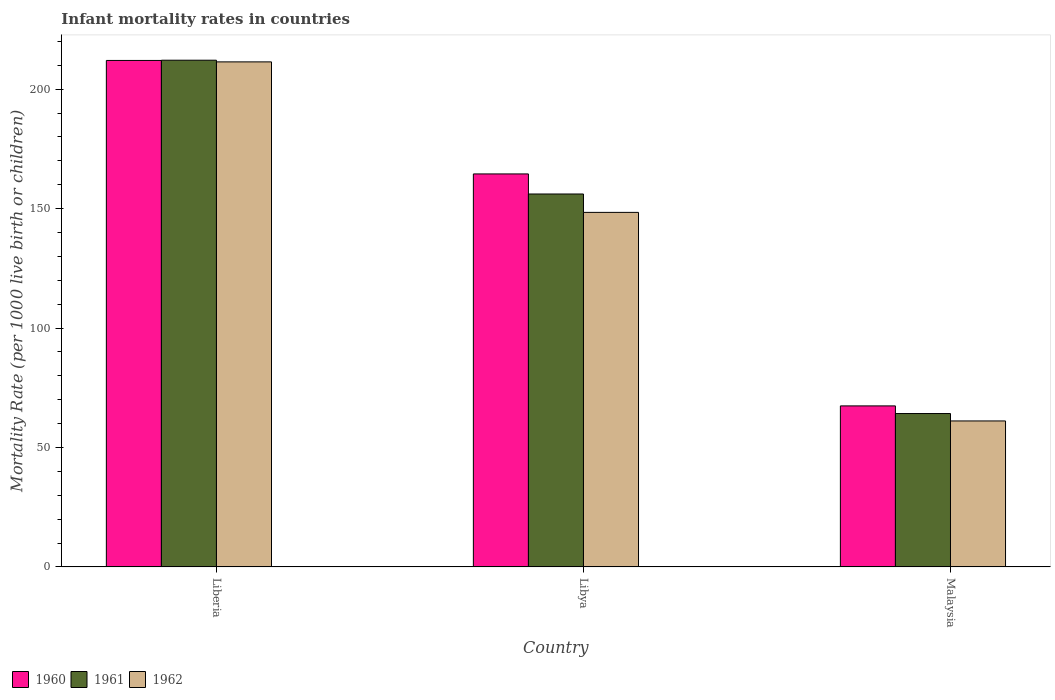How many different coloured bars are there?
Give a very brief answer. 3. How many bars are there on the 2nd tick from the right?
Make the answer very short. 3. What is the label of the 3rd group of bars from the left?
Ensure brevity in your answer.  Malaysia. What is the infant mortality rate in 1960 in Libya?
Your response must be concise. 164.5. Across all countries, what is the maximum infant mortality rate in 1961?
Offer a terse response. 212.1. Across all countries, what is the minimum infant mortality rate in 1961?
Provide a short and direct response. 64.2. In which country was the infant mortality rate in 1960 maximum?
Offer a terse response. Liberia. In which country was the infant mortality rate in 1960 minimum?
Make the answer very short. Malaysia. What is the total infant mortality rate in 1962 in the graph?
Give a very brief answer. 420.9. What is the difference between the infant mortality rate in 1962 in Liberia and that in Malaysia?
Provide a short and direct response. 150.3. What is the difference between the infant mortality rate in 1960 in Libya and the infant mortality rate in 1962 in Liberia?
Provide a succinct answer. -46.9. What is the average infant mortality rate in 1962 per country?
Make the answer very short. 140.3. What is the difference between the infant mortality rate of/in 1962 and infant mortality rate of/in 1960 in Liberia?
Your answer should be compact. -0.6. In how many countries, is the infant mortality rate in 1961 greater than 110?
Give a very brief answer. 2. What is the ratio of the infant mortality rate in 1960 in Liberia to that in Malaysia?
Offer a terse response. 3.15. Is the difference between the infant mortality rate in 1962 in Liberia and Malaysia greater than the difference between the infant mortality rate in 1960 in Liberia and Malaysia?
Your answer should be compact. Yes. What is the difference between the highest and the lowest infant mortality rate in 1961?
Keep it short and to the point. 147.9. What does the 1st bar from the left in Liberia represents?
Make the answer very short. 1960. Is it the case that in every country, the sum of the infant mortality rate in 1962 and infant mortality rate in 1961 is greater than the infant mortality rate in 1960?
Provide a succinct answer. Yes. How many bars are there?
Give a very brief answer. 9. Are all the bars in the graph horizontal?
Ensure brevity in your answer.  No. Does the graph contain grids?
Offer a terse response. No. What is the title of the graph?
Provide a short and direct response. Infant mortality rates in countries. Does "1974" appear as one of the legend labels in the graph?
Your answer should be very brief. No. What is the label or title of the X-axis?
Keep it short and to the point. Country. What is the label or title of the Y-axis?
Keep it short and to the point. Mortality Rate (per 1000 live birth or children). What is the Mortality Rate (per 1000 live birth or children) of 1960 in Liberia?
Provide a succinct answer. 212. What is the Mortality Rate (per 1000 live birth or children) of 1961 in Liberia?
Give a very brief answer. 212.1. What is the Mortality Rate (per 1000 live birth or children) in 1962 in Liberia?
Offer a terse response. 211.4. What is the Mortality Rate (per 1000 live birth or children) of 1960 in Libya?
Provide a short and direct response. 164.5. What is the Mortality Rate (per 1000 live birth or children) in 1961 in Libya?
Provide a succinct answer. 156.1. What is the Mortality Rate (per 1000 live birth or children) of 1962 in Libya?
Keep it short and to the point. 148.4. What is the Mortality Rate (per 1000 live birth or children) of 1960 in Malaysia?
Keep it short and to the point. 67.4. What is the Mortality Rate (per 1000 live birth or children) of 1961 in Malaysia?
Your response must be concise. 64.2. What is the Mortality Rate (per 1000 live birth or children) in 1962 in Malaysia?
Offer a very short reply. 61.1. Across all countries, what is the maximum Mortality Rate (per 1000 live birth or children) of 1960?
Keep it short and to the point. 212. Across all countries, what is the maximum Mortality Rate (per 1000 live birth or children) of 1961?
Provide a short and direct response. 212.1. Across all countries, what is the maximum Mortality Rate (per 1000 live birth or children) in 1962?
Provide a short and direct response. 211.4. Across all countries, what is the minimum Mortality Rate (per 1000 live birth or children) in 1960?
Offer a terse response. 67.4. Across all countries, what is the minimum Mortality Rate (per 1000 live birth or children) in 1961?
Offer a terse response. 64.2. Across all countries, what is the minimum Mortality Rate (per 1000 live birth or children) in 1962?
Offer a very short reply. 61.1. What is the total Mortality Rate (per 1000 live birth or children) of 1960 in the graph?
Ensure brevity in your answer.  443.9. What is the total Mortality Rate (per 1000 live birth or children) of 1961 in the graph?
Offer a terse response. 432.4. What is the total Mortality Rate (per 1000 live birth or children) in 1962 in the graph?
Keep it short and to the point. 420.9. What is the difference between the Mortality Rate (per 1000 live birth or children) of 1960 in Liberia and that in Libya?
Your response must be concise. 47.5. What is the difference between the Mortality Rate (per 1000 live birth or children) of 1962 in Liberia and that in Libya?
Your response must be concise. 63. What is the difference between the Mortality Rate (per 1000 live birth or children) in 1960 in Liberia and that in Malaysia?
Offer a terse response. 144.6. What is the difference between the Mortality Rate (per 1000 live birth or children) of 1961 in Liberia and that in Malaysia?
Offer a terse response. 147.9. What is the difference between the Mortality Rate (per 1000 live birth or children) in 1962 in Liberia and that in Malaysia?
Keep it short and to the point. 150.3. What is the difference between the Mortality Rate (per 1000 live birth or children) in 1960 in Libya and that in Malaysia?
Provide a succinct answer. 97.1. What is the difference between the Mortality Rate (per 1000 live birth or children) of 1961 in Libya and that in Malaysia?
Keep it short and to the point. 91.9. What is the difference between the Mortality Rate (per 1000 live birth or children) of 1962 in Libya and that in Malaysia?
Your response must be concise. 87.3. What is the difference between the Mortality Rate (per 1000 live birth or children) in 1960 in Liberia and the Mortality Rate (per 1000 live birth or children) in 1961 in Libya?
Provide a short and direct response. 55.9. What is the difference between the Mortality Rate (per 1000 live birth or children) of 1960 in Liberia and the Mortality Rate (per 1000 live birth or children) of 1962 in Libya?
Your response must be concise. 63.6. What is the difference between the Mortality Rate (per 1000 live birth or children) in 1961 in Liberia and the Mortality Rate (per 1000 live birth or children) in 1962 in Libya?
Keep it short and to the point. 63.7. What is the difference between the Mortality Rate (per 1000 live birth or children) of 1960 in Liberia and the Mortality Rate (per 1000 live birth or children) of 1961 in Malaysia?
Make the answer very short. 147.8. What is the difference between the Mortality Rate (per 1000 live birth or children) in 1960 in Liberia and the Mortality Rate (per 1000 live birth or children) in 1962 in Malaysia?
Keep it short and to the point. 150.9. What is the difference between the Mortality Rate (per 1000 live birth or children) in 1961 in Liberia and the Mortality Rate (per 1000 live birth or children) in 1962 in Malaysia?
Your answer should be compact. 151. What is the difference between the Mortality Rate (per 1000 live birth or children) in 1960 in Libya and the Mortality Rate (per 1000 live birth or children) in 1961 in Malaysia?
Your answer should be very brief. 100.3. What is the difference between the Mortality Rate (per 1000 live birth or children) in 1960 in Libya and the Mortality Rate (per 1000 live birth or children) in 1962 in Malaysia?
Your response must be concise. 103.4. What is the difference between the Mortality Rate (per 1000 live birth or children) of 1961 in Libya and the Mortality Rate (per 1000 live birth or children) of 1962 in Malaysia?
Ensure brevity in your answer.  95. What is the average Mortality Rate (per 1000 live birth or children) of 1960 per country?
Offer a very short reply. 147.97. What is the average Mortality Rate (per 1000 live birth or children) of 1961 per country?
Keep it short and to the point. 144.13. What is the average Mortality Rate (per 1000 live birth or children) in 1962 per country?
Make the answer very short. 140.3. What is the difference between the Mortality Rate (per 1000 live birth or children) in 1960 and Mortality Rate (per 1000 live birth or children) in 1961 in Liberia?
Make the answer very short. -0.1. What is the difference between the Mortality Rate (per 1000 live birth or children) in 1960 and Mortality Rate (per 1000 live birth or children) in 1962 in Liberia?
Give a very brief answer. 0.6. What is the difference between the Mortality Rate (per 1000 live birth or children) of 1961 and Mortality Rate (per 1000 live birth or children) of 1962 in Liberia?
Your answer should be very brief. 0.7. What is the difference between the Mortality Rate (per 1000 live birth or children) in 1961 and Mortality Rate (per 1000 live birth or children) in 1962 in Libya?
Offer a very short reply. 7.7. What is the difference between the Mortality Rate (per 1000 live birth or children) in 1961 and Mortality Rate (per 1000 live birth or children) in 1962 in Malaysia?
Make the answer very short. 3.1. What is the ratio of the Mortality Rate (per 1000 live birth or children) in 1960 in Liberia to that in Libya?
Your answer should be compact. 1.29. What is the ratio of the Mortality Rate (per 1000 live birth or children) of 1961 in Liberia to that in Libya?
Offer a terse response. 1.36. What is the ratio of the Mortality Rate (per 1000 live birth or children) in 1962 in Liberia to that in Libya?
Ensure brevity in your answer.  1.42. What is the ratio of the Mortality Rate (per 1000 live birth or children) of 1960 in Liberia to that in Malaysia?
Give a very brief answer. 3.15. What is the ratio of the Mortality Rate (per 1000 live birth or children) of 1961 in Liberia to that in Malaysia?
Your answer should be compact. 3.3. What is the ratio of the Mortality Rate (per 1000 live birth or children) in 1962 in Liberia to that in Malaysia?
Make the answer very short. 3.46. What is the ratio of the Mortality Rate (per 1000 live birth or children) of 1960 in Libya to that in Malaysia?
Offer a terse response. 2.44. What is the ratio of the Mortality Rate (per 1000 live birth or children) of 1961 in Libya to that in Malaysia?
Your response must be concise. 2.43. What is the ratio of the Mortality Rate (per 1000 live birth or children) of 1962 in Libya to that in Malaysia?
Provide a succinct answer. 2.43. What is the difference between the highest and the second highest Mortality Rate (per 1000 live birth or children) of 1960?
Your answer should be compact. 47.5. What is the difference between the highest and the second highest Mortality Rate (per 1000 live birth or children) in 1961?
Make the answer very short. 56. What is the difference between the highest and the second highest Mortality Rate (per 1000 live birth or children) of 1962?
Your answer should be compact. 63. What is the difference between the highest and the lowest Mortality Rate (per 1000 live birth or children) in 1960?
Offer a terse response. 144.6. What is the difference between the highest and the lowest Mortality Rate (per 1000 live birth or children) of 1961?
Give a very brief answer. 147.9. What is the difference between the highest and the lowest Mortality Rate (per 1000 live birth or children) in 1962?
Ensure brevity in your answer.  150.3. 